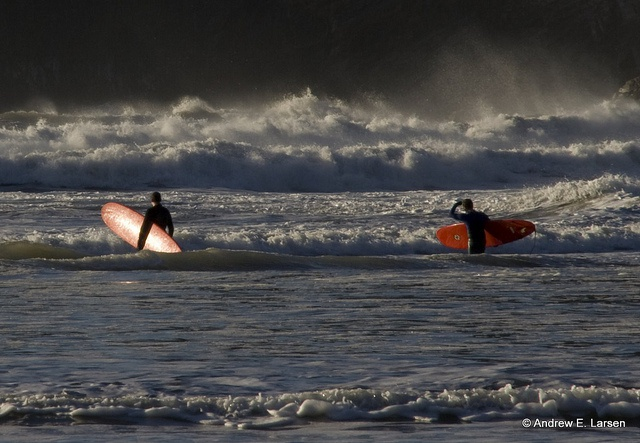Describe the objects in this image and their specific colors. I can see surfboard in black, tan, ivory, and salmon tones, surfboard in black, maroon, and brown tones, people in black, gray, maroon, and brown tones, and people in black, gray, darkgray, and maroon tones in this image. 